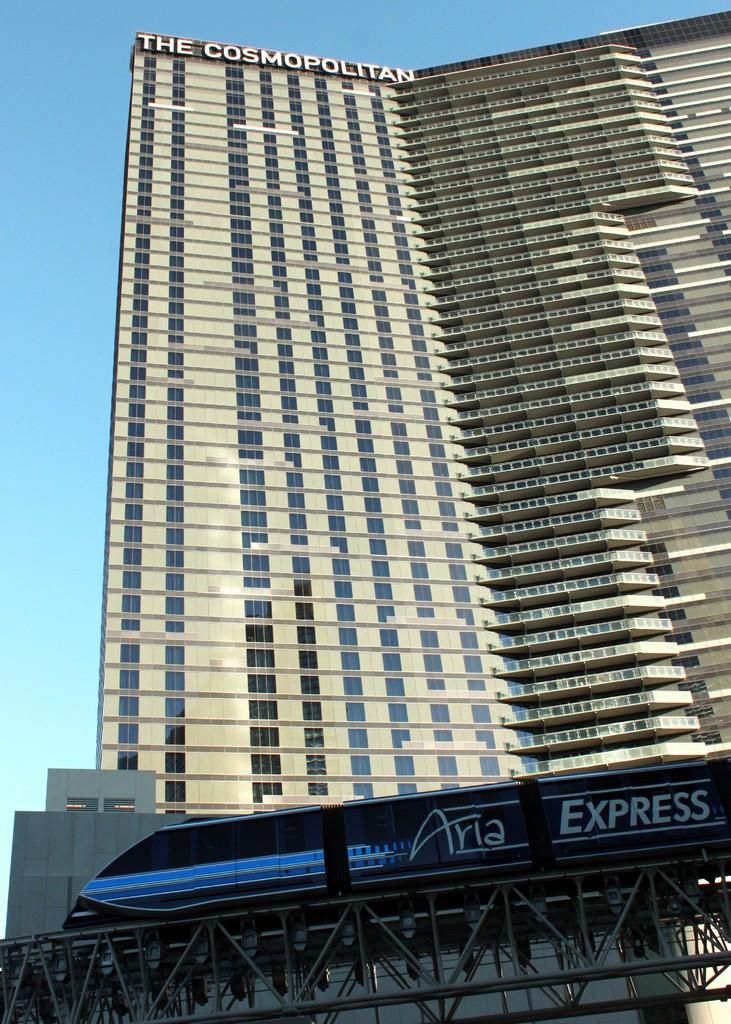What is the name on the bus?
Provide a short and direct response. Aria express. What is the name of the building?
Your response must be concise. The cosmopolitan. 